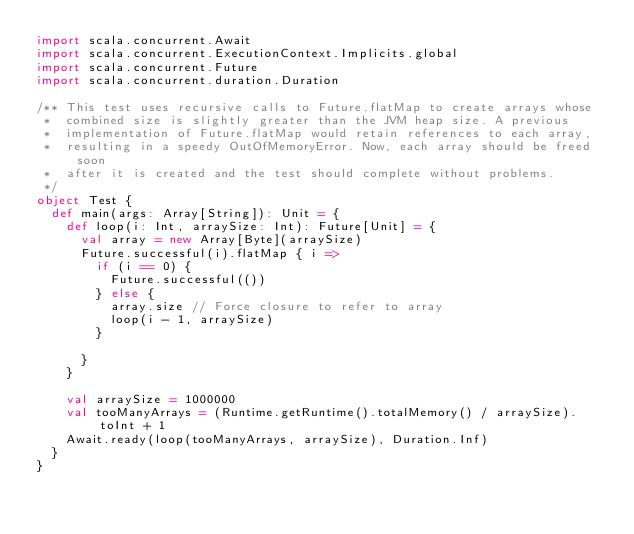<code> <loc_0><loc_0><loc_500><loc_500><_Scala_>import scala.concurrent.Await
import scala.concurrent.ExecutionContext.Implicits.global
import scala.concurrent.Future
import scala.concurrent.duration.Duration

/** This test uses recursive calls to Future.flatMap to create arrays whose
 *  combined size is slightly greater than the JVM heap size. A previous
 *  implementation of Future.flatMap would retain references to each array,
 *  resulting in a speedy OutOfMemoryError. Now, each array should be freed soon
 *  after it is created and the test should complete without problems.
 */
object Test {
  def main(args: Array[String]): Unit = {
    def loop(i: Int, arraySize: Int): Future[Unit] = {
      val array = new Array[Byte](arraySize)
      Future.successful(i).flatMap { i =>
        if (i == 0) {
          Future.successful(())
        } else {
          array.size // Force closure to refer to array
          loop(i - 1, arraySize)
        }

      }
    }

    val arraySize = 1000000
    val tooManyArrays = (Runtime.getRuntime().totalMemory() / arraySize).toInt + 1
    Await.ready(loop(tooManyArrays, arraySize), Duration.Inf)
  }
}
</code> 